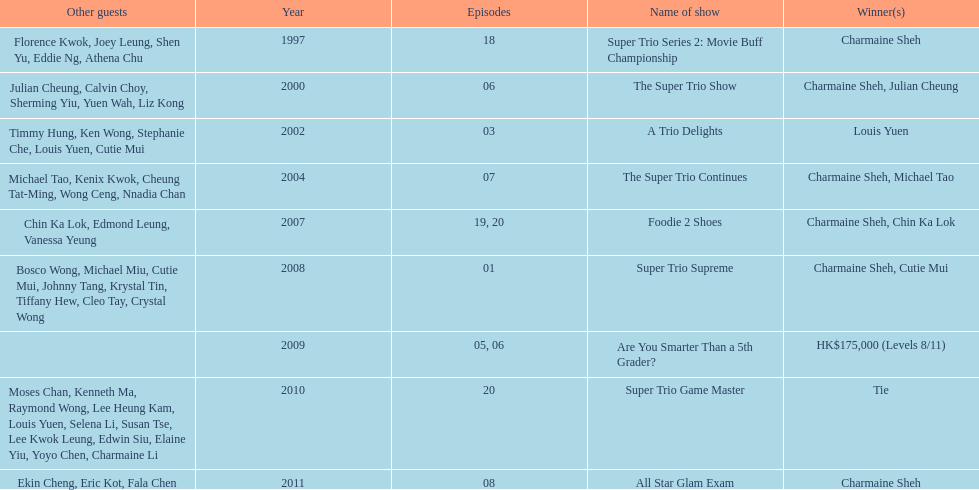How long has it been since chermaine sheh first appeared on a variety show? 17 years. 